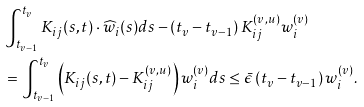<formula> <loc_0><loc_0><loc_500><loc_500>& \int _ { t _ { v - 1 } } ^ { t _ { v } } K _ { i j } ( s , t ) \cdot \widehat { w } _ { i } ( s ) d s - \left ( t _ { v } - t _ { v - 1 } \right ) K _ { i j } ^ { ( v , u ) } w _ { i } ^ { ( v ) } \\ & = \int _ { t _ { v - 1 } } ^ { t _ { v } } \left ( K _ { i j } ( s , t ) - K _ { i j } ^ { ( v , u ) } \right ) w _ { i } ^ { ( v ) } d s \leq \bar { \epsilon } \left ( t _ { v } - t _ { v - 1 } \right ) w _ { i } ^ { ( v ) } .</formula> 